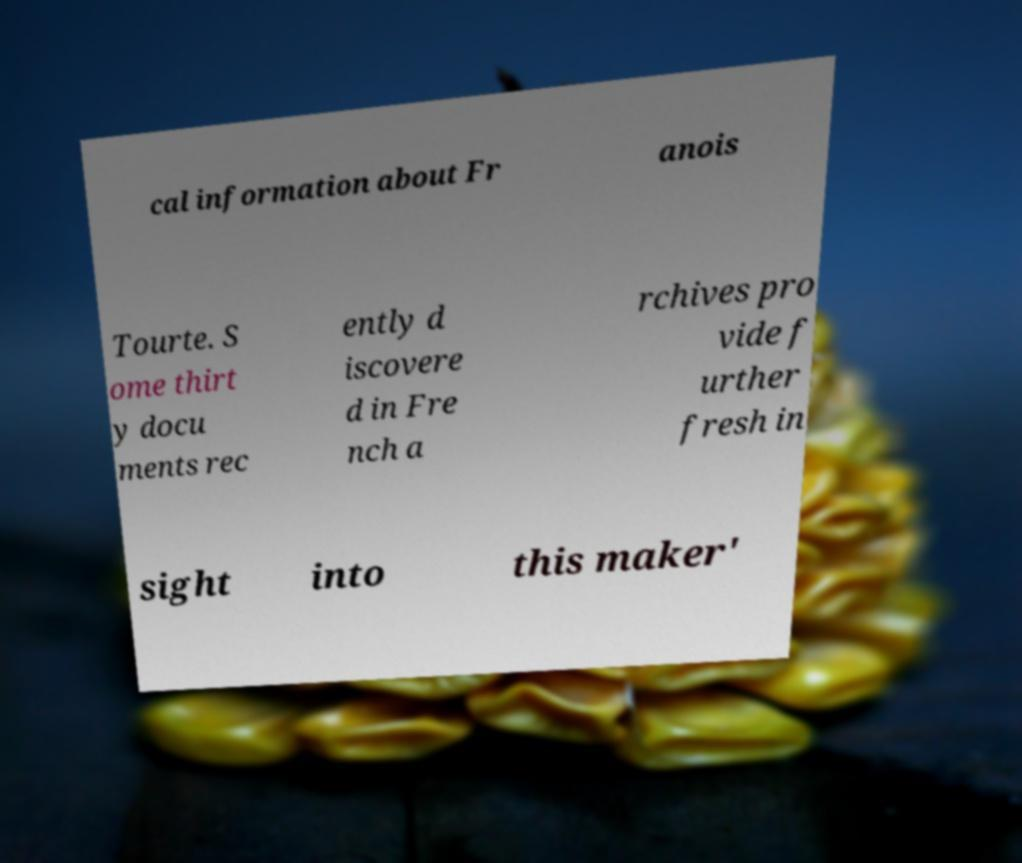There's text embedded in this image that I need extracted. Can you transcribe it verbatim? cal information about Fr anois Tourte. S ome thirt y docu ments rec ently d iscovere d in Fre nch a rchives pro vide f urther fresh in sight into this maker' 